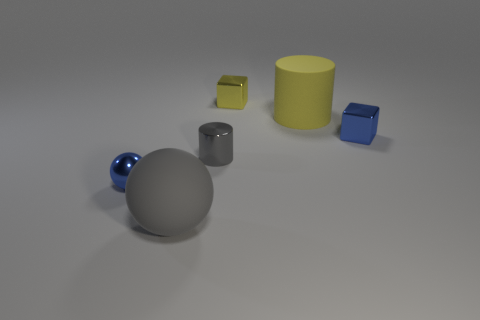Add 3 large cylinders. How many objects exist? 9 Subtract 0 cyan blocks. How many objects are left? 6 Subtract all big yellow matte cylinders. Subtract all blue shiny cubes. How many objects are left? 4 Add 1 small yellow things. How many small yellow things are left? 2 Add 6 large blue rubber balls. How many large blue rubber balls exist? 6 